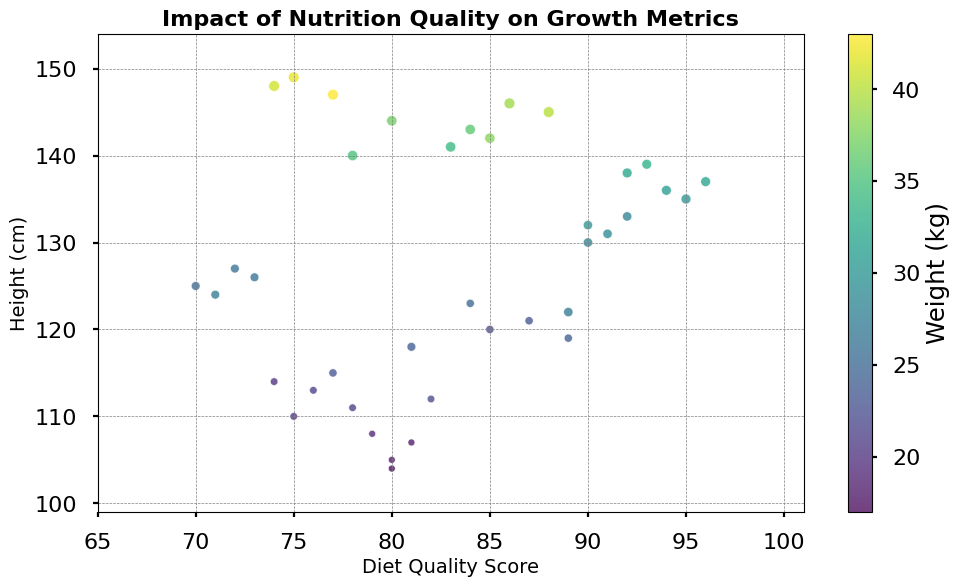How does the height generally vary with diet quality scores? Looking at the scatter plot, we notice a positive trend where higher diet quality scores are associated with taller heights.
Answer: Taller heights with higher scores For a child with a diet quality score of around 90, what range of heights can we expect to see? Examining the data points near the diet quality score of 90, we observe that heights range approximately from 130 cm to 145 cm.
Answer: 130 cm to 145 cm Which factor is represented by the size of the markers, and how does it vary across the plot? The size of the markers corresponds to the age of the children; larger markers indicate older children, and smaller markers indicate younger children.
Answer: Age What is the relationship between diet quality score and weight? The color bar indicates that as diet quality scores increase, the weight tends to show some variation without a clear trend but generally ranging from light to moderate weights.
Answer: Varied without clear trend Which child has the lowest height and what is their diet quality score? Identifying the lowest height on the plot, it is 104 cm. The corresponding diet quality score for this child appears to be 80.
Answer: 80 How does weight change across different heights for a given diet quality score range (e.g., around 80-85)? Observing the marker colors for scores between 80-85, weight shows variations but often tilts towards moderate values. For example, heights around 120-125 cm have weights typically between 22-25 kg.
Answer: 22-25 kg for 120-125 cm heights Are there any age groups that are underrepresented in the dataset? By observing the sizes of the markers, it appears that there are fewer data points for the very young or very old age groups as larger and smaller markers are less frequent.
Answer: Very young and very old Among children with diet quality scores above 90, what is the common height range noticed? For diet quality scores above 90, the heights generally fall between 130 cm and 149 cm as observed from the upper right portion of the scatter plot.
Answer: 130 cm to 149 cm Is there any significant cluster or pattern visible in the plot in terms of diet quality and growth metrics? There is a visible cluster around mid-range diet quality scores (70-85) with a diverse spread in height and weight, showing that moderate diet quality corresponds to a wide range of growth outcomes.
Answer: Cluster around 70-85 Between children aged 5 and 7, do children with a higher diet quality score show taller heights? Comparing marker sizes and positions, children aged 5-7 generally show taller heights with higher diet quality scores, confirming the impact of better diet quality.
Answer: Yes 